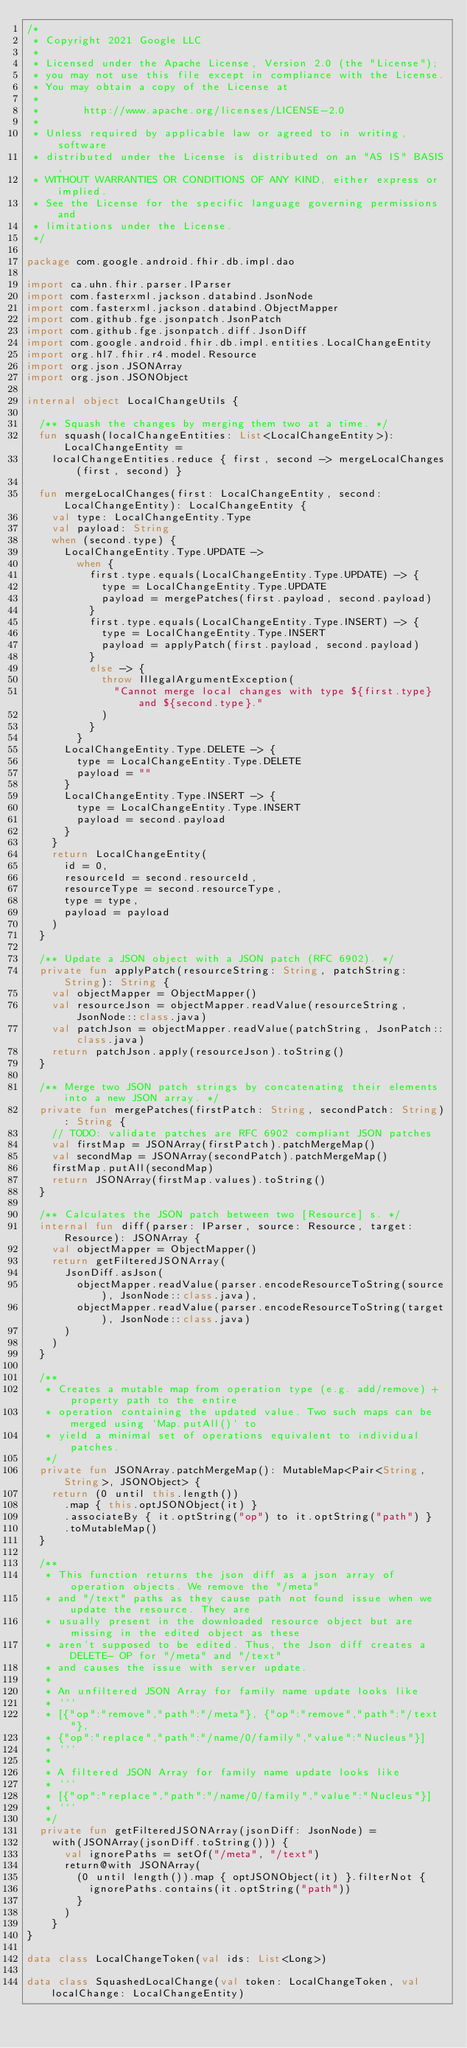<code> <loc_0><loc_0><loc_500><loc_500><_Kotlin_>/*
 * Copyright 2021 Google LLC
 *
 * Licensed under the Apache License, Version 2.0 (the "License");
 * you may not use this file except in compliance with the License.
 * You may obtain a copy of the License at
 *
 *       http://www.apache.org/licenses/LICENSE-2.0
 *
 * Unless required by applicable law or agreed to in writing, software
 * distributed under the License is distributed on an "AS IS" BASIS,
 * WITHOUT WARRANTIES OR CONDITIONS OF ANY KIND, either express or implied.
 * See the License for the specific language governing permissions and
 * limitations under the License.
 */

package com.google.android.fhir.db.impl.dao

import ca.uhn.fhir.parser.IParser
import com.fasterxml.jackson.databind.JsonNode
import com.fasterxml.jackson.databind.ObjectMapper
import com.github.fge.jsonpatch.JsonPatch
import com.github.fge.jsonpatch.diff.JsonDiff
import com.google.android.fhir.db.impl.entities.LocalChangeEntity
import org.hl7.fhir.r4.model.Resource
import org.json.JSONArray
import org.json.JSONObject

internal object LocalChangeUtils {

  /** Squash the changes by merging them two at a time. */
  fun squash(localChangeEntities: List<LocalChangeEntity>): LocalChangeEntity =
    localChangeEntities.reduce { first, second -> mergeLocalChanges(first, second) }

  fun mergeLocalChanges(first: LocalChangeEntity, second: LocalChangeEntity): LocalChangeEntity {
    val type: LocalChangeEntity.Type
    val payload: String
    when (second.type) {
      LocalChangeEntity.Type.UPDATE ->
        when {
          first.type.equals(LocalChangeEntity.Type.UPDATE) -> {
            type = LocalChangeEntity.Type.UPDATE
            payload = mergePatches(first.payload, second.payload)
          }
          first.type.equals(LocalChangeEntity.Type.INSERT) -> {
            type = LocalChangeEntity.Type.INSERT
            payload = applyPatch(first.payload, second.payload)
          }
          else -> {
            throw IllegalArgumentException(
              "Cannot merge local changes with type ${first.type} and ${second.type}."
            )
          }
        }
      LocalChangeEntity.Type.DELETE -> {
        type = LocalChangeEntity.Type.DELETE
        payload = ""
      }
      LocalChangeEntity.Type.INSERT -> {
        type = LocalChangeEntity.Type.INSERT
        payload = second.payload
      }
    }
    return LocalChangeEntity(
      id = 0,
      resourceId = second.resourceId,
      resourceType = second.resourceType,
      type = type,
      payload = payload
    )
  }

  /** Update a JSON object with a JSON patch (RFC 6902). */
  private fun applyPatch(resourceString: String, patchString: String): String {
    val objectMapper = ObjectMapper()
    val resourceJson = objectMapper.readValue(resourceString, JsonNode::class.java)
    val patchJson = objectMapper.readValue(patchString, JsonPatch::class.java)
    return patchJson.apply(resourceJson).toString()
  }

  /** Merge two JSON patch strings by concatenating their elements into a new JSON array. */
  private fun mergePatches(firstPatch: String, secondPatch: String): String {
    // TODO: validate patches are RFC 6902 compliant JSON patches
    val firstMap = JSONArray(firstPatch).patchMergeMap()
    val secondMap = JSONArray(secondPatch).patchMergeMap()
    firstMap.putAll(secondMap)
    return JSONArray(firstMap.values).toString()
  }

  /** Calculates the JSON patch between two [Resource] s. */
  internal fun diff(parser: IParser, source: Resource, target: Resource): JSONArray {
    val objectMapper = ObjectMapper()
    return getFilteredJSONArray(
      JsonDiff.asJson(
        objectMapper.readValue(parser.encodeResourceToString(source), JsonNode::class.java),
        objectMapper.readValue(parser.encodeResourceToString(target), JsonNode::class.java)
      )
    )
  }

  /**
   * Creates a mutable map from operation type (e.g. add/remove) + property path to the entire
   * operation containing the updated value. Two such maps can be merged using `Map.putAll()` to
   * yield a minimal set of operations equivalent to individual patches.
   */
  private fun JSONArray.patchMergeMap(): MutableMap<Pair<String, String>, JSONObject> {
    return (0 until this.length())
      .map { this.optJSONObject(it) }
      .associateBy { it.optString("op") to it.optString("path") }
      .toMutableMap()
  }

  /**
   * This function returns the json diff as a json array of operation objects. We remove the "/meta"
   * and "/text" paths as they cause path not found issue when we update the resource. They are
   * usually present in the downloaded resource object but are missing in the edited object as these
   * aren't supposed to be edited. Thus, the Json diff creates a DELETE- OP for "/meta" and "/text"
   * and causes the issue with server update.
   *
   * An unfiltered JSON Array for family name update looks like
   * ```
   * [{"op":"remove","path":"/meta"}, {"op":"remove","path":"/text"},
   * {"op":"replace","path":"/name/0/family","value":"Nucleus"}]
   * ```
   *
   * A filtered JSON Array for family name update looks like
   * ```
   * [{"op":"replace","path":"/name/0/family","value":"Nucleus"}]
   * ```
   */
  private fun getFilteredJSONArray(jsonDiff: JsonNode) =
    with(JSONArray(jsonDiff.toString())) {
      val ignorePaths = setOf("/meta", "/text")
      return@with JSONArray(
        (0 until length()).map { optJSONObject(it) }.filterNot {
          ignorePaths.contains(it.optString("path"))
        }
      )
    }
}

data class LocalChangeToken(val ids: List<Long>)

data class SquashedLocalChange(val token: LocalChangeToken, val localChange: LocalChangeEntity)
</code> 